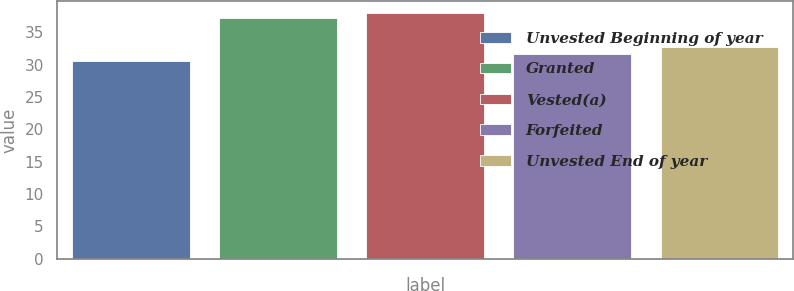<chart> <loc_0><loc_0><loc_500><loc_500><bar_chart><fcel>Unvested Beginning of year<fcel>Granted<fcel>Vested(a)<fcel>Forfeited<fcel>Unvested End of year<nl><fcel>30.63<fcel>37.28<fcel>37.95<fcel>31.63<fcel>32.71<nl></chart> 